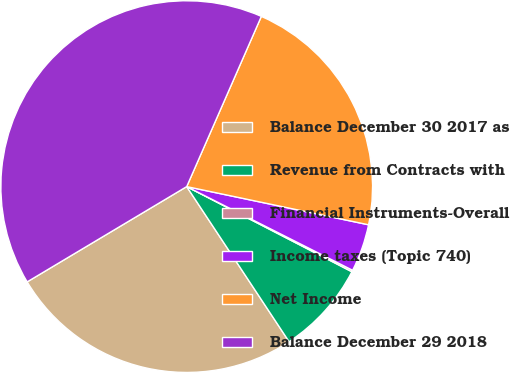Convert chart. <chart><loc_0><loc_0><loc_500><loc_500><pie_chart><fcel>Balance December 30 2017 as<fcel>Revenue from Contracts with<fcel>Financial Instruments-Overall<fcel>Income taxes (Topic 740)<fcel>Net Income<fcel>Balance December 29 2018<nl><fcel>25.72%<fcel>8.14%<fcel>0.14%<fcel>4.14%<fcel>21.72%<fcel>40.15%<nl></chart> 